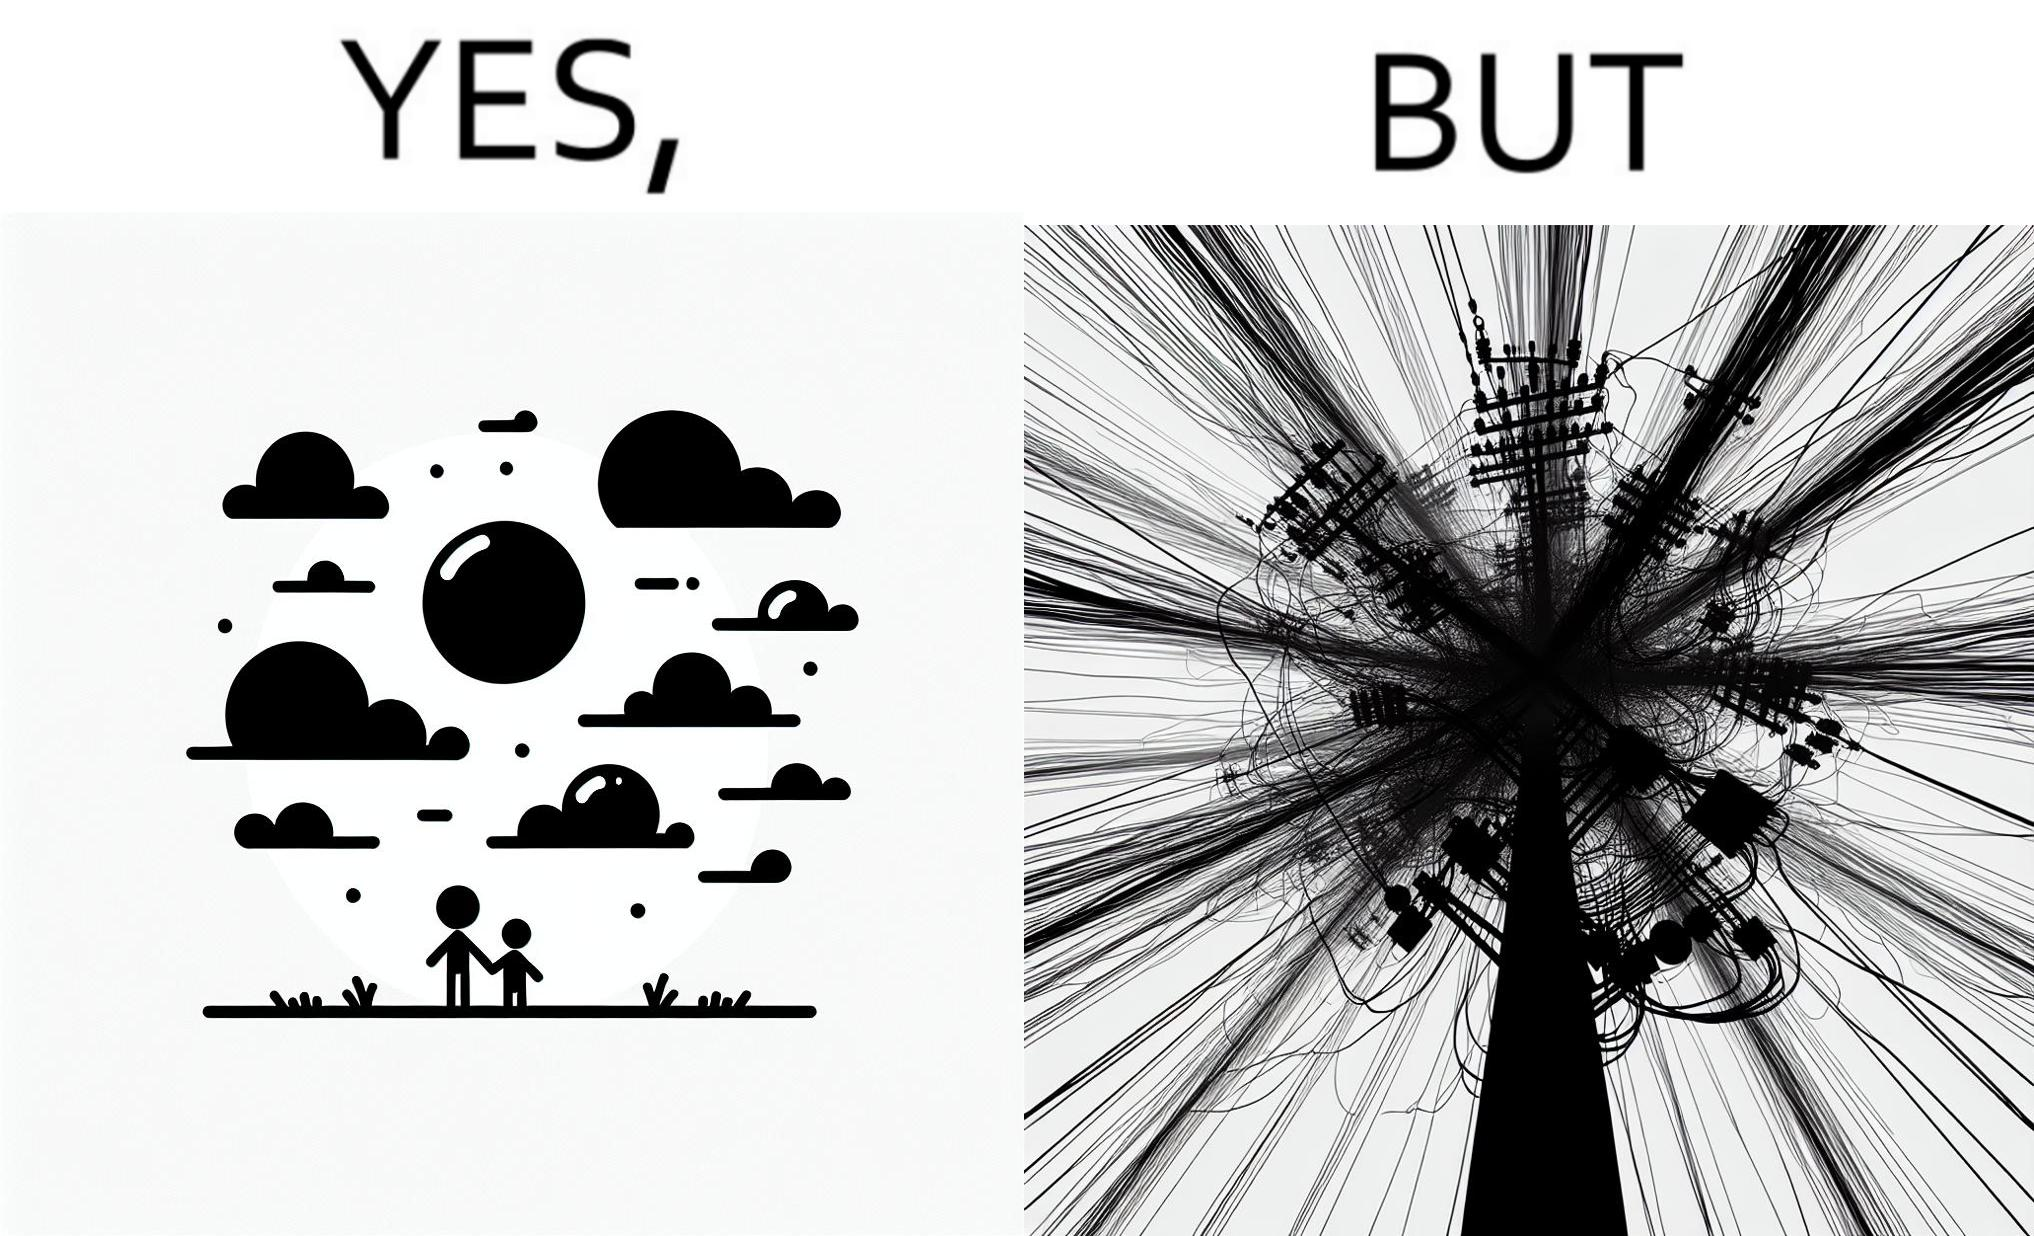Describe what you see in the left and right parts of this image. In the left part of the image: a clear sky with sun and clouds In the right part of the image: an electricity pole with a lot of wires over it 